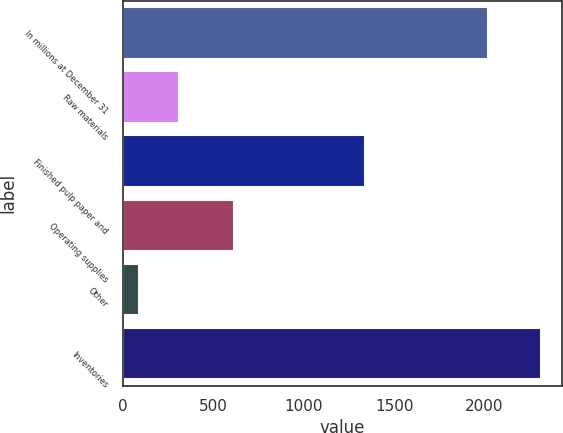<chart> <loc_0><loc_0><loc_500><loc_500><bar_chart><fcel>In millions at December 31<fcel>Raw materials<fcel>Finished pulp paper and<fcel>Operating supplies<fcel>Other<fcel>Inventories<nl><fcel>2017<fcel>309.6<fcel>1337<fcel>615<fcel>87<fcel>2313<nl></chart> 